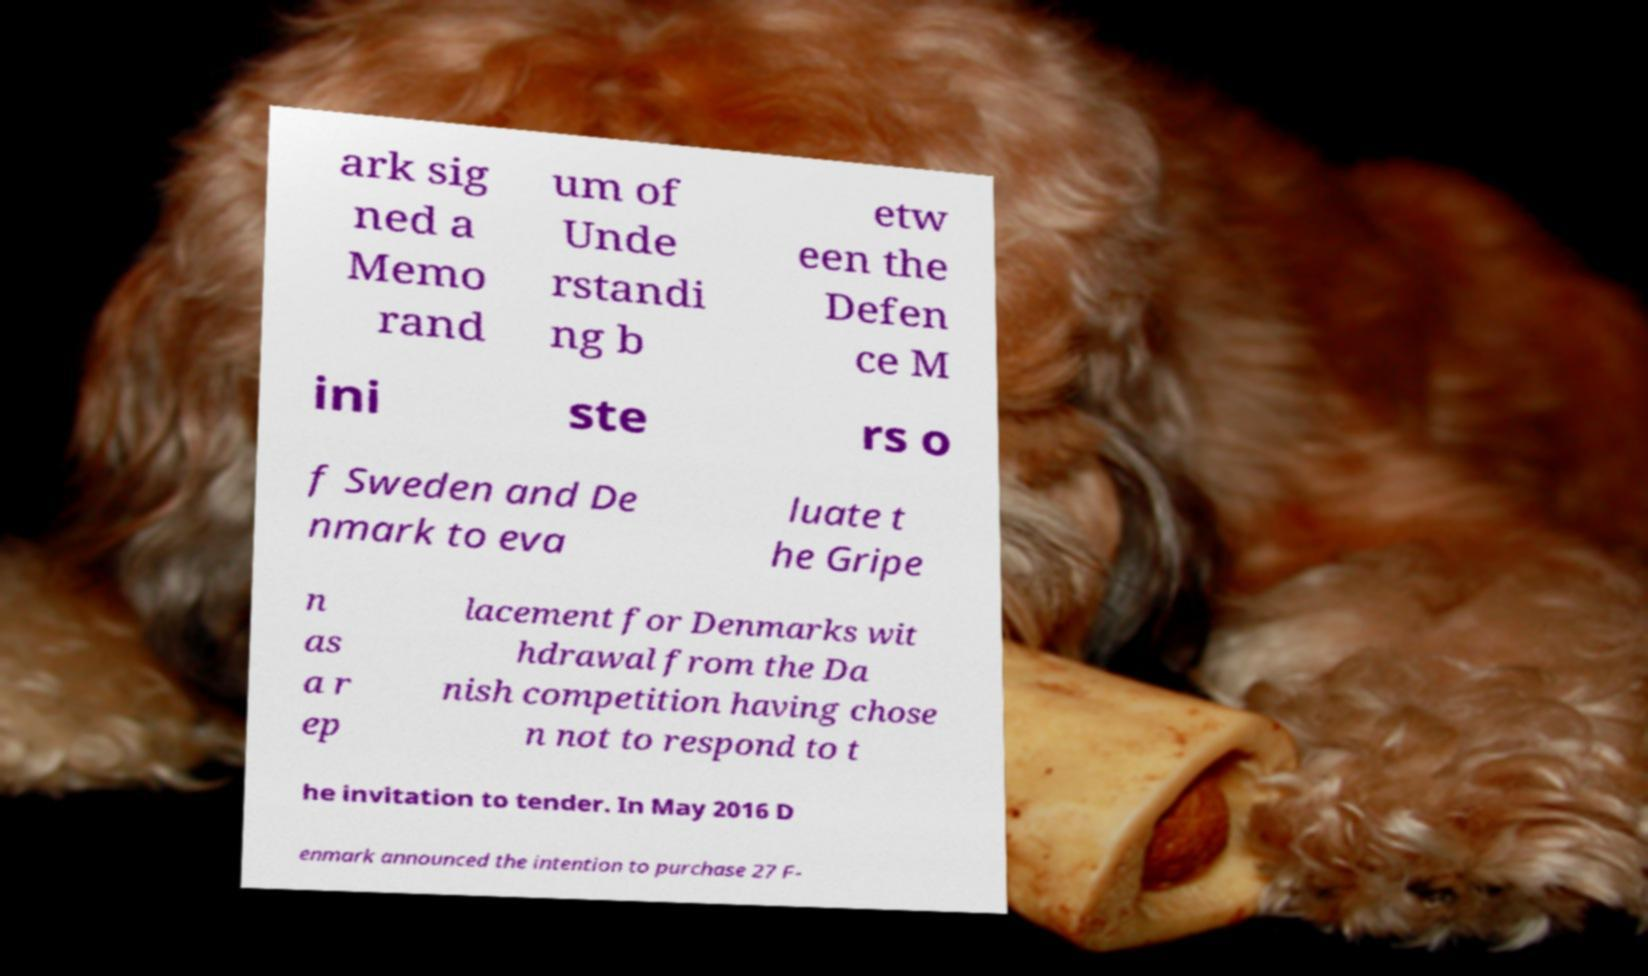There's text embedded in this image that I need extracted. Can you transcribe it verbatim? ark sig ned a Memo rand um of Unde rstandi ng b etw een the Defen ce M ini ste rs o f Sweden and De nmark to eva luate t he Gripe n as a r ep lacement for Denmarks wit hdrawal from the Da nish competition having chose n not to respond to t he invitation to tender. In May 2016 D enmark announced the intention to purchase 27 F- 